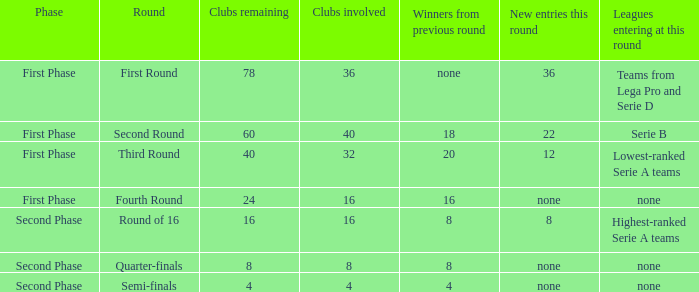In which stage can you locate the 12 new entries for this round? First Phase. 